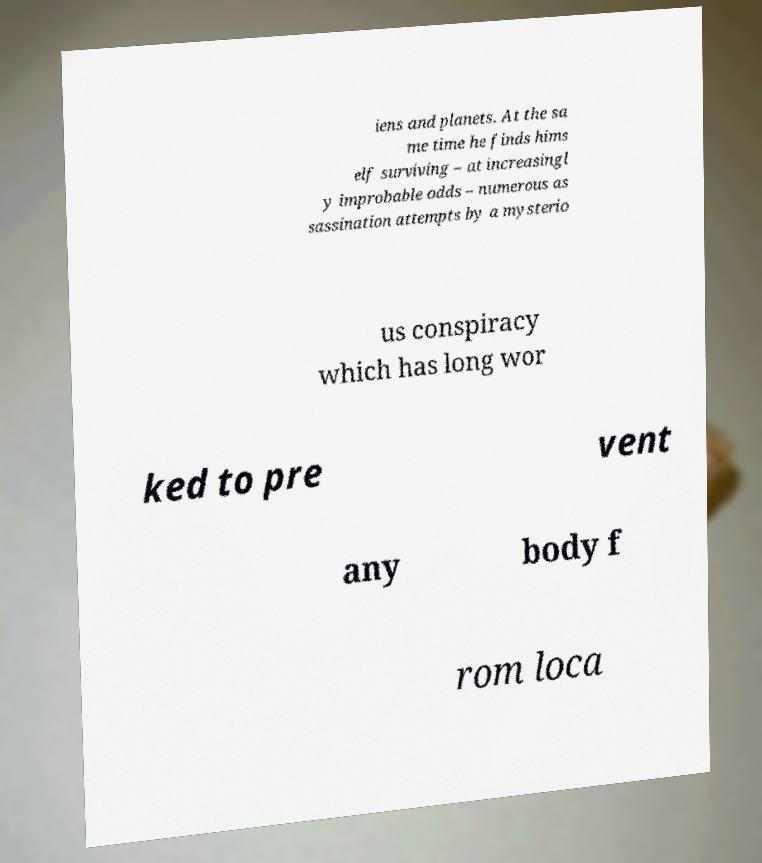For documentation purposes, I need the text within this image transcribed. Could you provide that? iens and planets. At the sa me time he finds hims elf surviving – at increasingl y improbable odds – numerous as sassination attempts by a mysterio us conspiracy which has long wor ked to pre vent any body f rom loca 